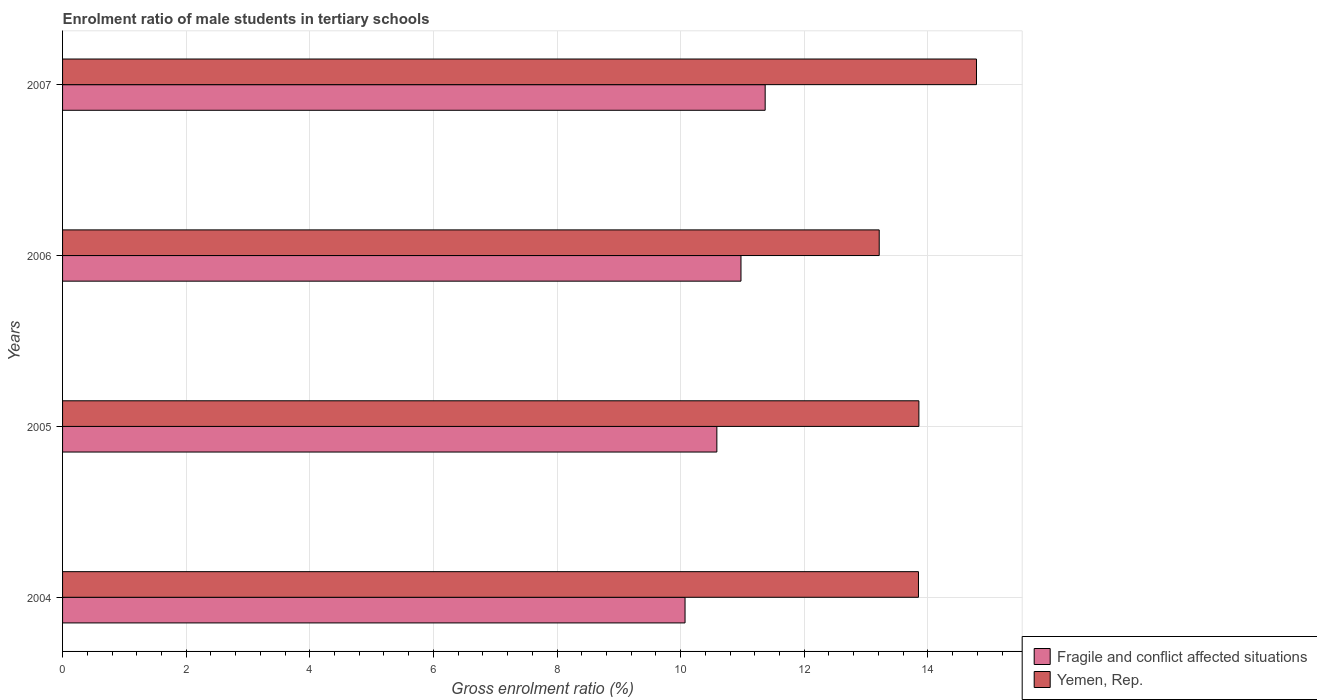How many different coloured bars are there?
Provide a succinct answer. 2. Are the number of bars per tick equal to the number of legend labels?
Your answer should be compact. Yes. What is the label of the 4th group of bars from the top?
Give a very brief answer. 2004. In how many cases, is the number of bars for a given year not equal to the number of legend labels?
Offer a terse response. 0. What is the enrolment ratio of male students in tertiary schools in Fragile and conflict affected situations in 2006?
Ensure brevity in your answer.  10.98. Across all years, what is the maximum enrolment ratio of male students in tertiary schools in Yemen, Rep.?
Offer a very short reply. 14.79. Across all years, what is the minimum enrolment ratio of male students in tertiary schools in Fragile and conflict affected situations?
Provide a succinct answer. 10.07. What is the total enrolment ratio of male students in tertiary schools in Fragile and conflict affected situations in the graph?
Your response must be concise. 43. What is the difference between the enrolment ratio of male students in tertiary schools in Fragile and conflict affected situations in 2004 and that in 2006?
Offer a terse response. -0.9. What is the difference between the enrolment ratio of male students in tertiary schools in Yemen, Rep. in 2004 and the enrolment ratio of male students in tertiary schools in Fragile and conflict affected situations in 2005?
Provide a short and direct response. 3.26. What is the average enrolment ratio of male students in tertiary schools in Yemen, Rep. per year?
Make the answer very short. 13.93. In the year 2004, what is the difference between the enrolment ratio of male students in tertiary schools in Fragile and conflict affected situations and enrolment ratio of male students in tertiary schools in Yemen, Rep.?
Your answer should be compact. -3.78. In how many years, is the enrolment ratio of male students in tertiary schools in Fragile and conflict affected situations greater than 0.8 %?
Give a very brief answer. 4. What is the ratio of the enrolment ratio of male students in tertiary schools in Yemen, Rep. in 2005 to that in 2006?
Ensure brevity in your answer.  1.05. Is the enrolment ratio of male students in tertiary schools in Fragile and conflict affected situations in 2005 less than that in 2007?
Your answer should be compact. Yes. What is the difference between the highest and the second highest enrolment ratio of male students in tertiary schools in Fragile and conflict affected situations?
Keep it short and to the point. 0.39. What is the difference between the highest and the lowest enrolment ratio of male students in tertiary schools in Yemen, Rep.?
Provide a short and direct response. 1.57. What does the 2nd bar from the top in 2006 represents?
Make the answer very short. Fragile and conflict affected situations. What does the 2nd bar from the bottom in 2007 represents?
Offer a very short reply. Yemen, Rep. How many bars are there?
Your response must be concise. 8. What is the difference between two consecutive major ticks on the X-axis?
Offer a very short reply. 2. Are the values on the major ticks of X-axis written in scientific E-notation?
Give a very brief answer. No. Does the graph contain any zero values?
Your answer should be compact. No. Does the graph contain grids?
Make the answer very short. Yes. What is the title of the graph?
Provide a short and direct response. Enrolment ratio of male students in tertiary schools. Does "Peru" appear as one of the legend labels in the graph?
Your answer should be very brief. No. What is the label or title of the X-axis?
Make the answer very short. Gross enrolment ratio (%). What is the Gross enrolment ratio (%) in Fragile and conflict affected situations in 2004?
Offer a terse response. 10.07. What is the Gross enrolment ratio (%) in Yemen, Rep. in 2004?
Your answer should be compact. 13.85. What is the Gross enrolment ratio (%) in Fragile and conflict affected situations in 2005?
Your answer should be very brief. 10.59. What is the Gross enrolment ratio (%) in Yemen, Rep. in 2005?
Ensure brevity in your answer.  13.85. What is the Gross enrolment ratio (%) in Fragile and conflict affected situations in 2006?
Your answer should be very brief. 10.98. What is the Gross enrolment ratio (%) in Yemen, Rep. in 2006?
Ensure brevity in your answer.  13.21. What is the Gross enrolment ratio (%) of Fragile and conflict affected situations in 2007?
Your answer should be very brief. 11.37. What is the Gross enrolment ratio (%) of Yemen, Rep. in 2007?
Keep it short and to the point. 14.79. Across all years, what is the maximum Gross enrolment ratio (%) of Fragile and conflict affected situations?
Give a very brief answer. 11.37. Across all years, what is the maximum Gross enrolment ratio (%) in Yemen, Rep.?
Make the answer very short. 14.79. Across all years, what is the minimum Gross enrolment ratio (%) in Fragile and conflict affected situations?
Keep it short and to the point. 10.07. Across all years, what is the minimum Gross enrolment ratio (%) in Yemen, Rep.?
Provide a short and direct response. 13.21. What is the total Gross enrolment ratio (%) of Fragile and conflict affected situations in the graph?
Give a very brief answer. 43. What is the total Gross enrolment ratio (%) of Yemen, Rep. in the graph?
Give a very brief answer. 55.7. What is the difference between the Gross enrolment ratio (%) in Fragile and conflict affected situations in 2004 and that in 2005?
Keep it short and to the point. -0.51. What is the difference between the Gross enrolment ratio (%) in Yemen, Rep. in 2004 and that in 2005?
Give a very brief answer. -0.01. What is the difference between the Gross enrolment ratio (%) in Fragile and conflict affected situations in 2004 and that in 2006?
Provide a succinct answer. -0.91. What is the difference between the Gross enrolment ratio (%) of Yemen, Rep. in 2004 and that in 2006?
Make the answer very short. 0.64. What is the difference between the Gross enrolment ratio (%) in Fragile and conflict affected situations in 2004 and that in 2007?
Your response must be concise. -1.3. What is the difference between the Gross enrolment ratio (%) in Yemen, Rep. in 2004 and that in 2007?
Provide a short and direct response. -0.94. What is the difference between the Gross enrolment ratio (%) of Fragile and conflict affected situations in 2005 and that in 2006?
Your answer should be compact. -0.39. What is the difference between the Gross enrolment ratio (%) in Yemen, Rep. in 2005 and that in 2006?
Your answer should be compact. 0.64. What is the difference between the Gross enrolment ratio (%) in Fragile and conflict affected situations in 2005 and that in 2007?
Offer a terse response. -0.78. What is the difference between the Gross enrolment ratio (%) of Yemen, Rep. in 2005 and that in 2007?
Your answer should be compact. -0.93. What is the difference between the Gross enrolment ratio (%) in Fragile and conflict affected situations in 2006 and that in 2007?
Provide a short and direct response. -0.39. What is the difference between the Gross enrolment ratio (%) of Yemen, Rep. in 2006 and that in 2007?
Provide a succinct answer. -1.57. What is the difference between the Gross enrolment ratio (%) of Fragile and conflict affected situations in 2004 and the Gross enrolment ratio (%) of Yemen, Rep. in 2005?
Your response must be concise. -3.78. What is the difference between the Gross enrolment ratio (%) in Fragile and conflict affected situations in 2004 and the Gross enrolment ratio (%) in Yemen, Rep. in 2006?
Your answer should be compact. -3.14. What is the difference between the Gross enrolment ratio (%) of Fragile and conflict affected situations in 2004 and the Gross enrolment ratio (%) of Yemen, Rep. in 2007?
Your response must be concise. -4.71. What is the difference between the Gross enrolment ratio (%) of Fragile and conflict affected situations in 2005 and the Gross enrolment ratio (%) of Yemen, Rep. in 2006?
Your answer should be very brief. -2.63. What is the difference between the Gross enrolment ratio (%) of Fragile and conflict affected situations in 2005 and the Gross enrolment ratio (%) of Yemen, Rep. in 2007?
Ensure brevity in your answer.  -4.2. What is the difference between the Gross enrolment ratio (%) of Fragile and conflict affected situations in 2006 and the Gross enrolment ratio (%) of Yemen, Rep. in 2007?
Your answer should be compact. -3.81. What is the average Gross enrolment ratio (%) in Fragile and conflict affected situations per year?
Your answer should be very brief. 10.75. What is the average Gross enrolment ratio (%) in Yemen, Rep. per year?
Offer a terse response. 13.93. In the year 2004, what is the difference between the Gross enrolment ratio (%) of Fragile and conflict affected situations and Gross enrolment ratio (%) of Yemen, Rep.?
Provide a short and direct response. -3.78. In the year 2005, what is the difference between the Gross enrolment ratio (%) in Fragile and conflict affected situations and Gross enrolment ratio (%) in Yemen, Rep.?
Provide a short and direct response. -3.27. In the year 2006, what is the difference between the Gross enrolment ratio (%) in Fragile and conflict affected situations and Gross enrolment ratio (%) in Yemen, Rep.?
Your response must be concise. -2.24. In the year 2007, what is the difference between the Gross enrolment ratio (%) of Fragile and conflict affected situations and Gross enrolment ratio (%) of Yemen, Rep.?
Make the answer very short. -3.42. What is the ratio of the Gross enrolment ratio (%) of Fragile and conflict affected situations in 2004 to that in 2005?
Provide a short and direct response. 0.95. What is the ratio of the Gross enrolment ratio (%) of Yemen, Rep. in 2004 to that in 2005?
Offer a very short reply. 1. What is the ratio of the Gross enrolment ratio (%) in Fragile and conflict affected situations in 2004 to that in 2006?
Your answer should be compact. 0.92. What is the ratio of the Gross enrolment ratio (%) of Yemen, Rep. in 2004 to that in 2006?
Offer a terse response. 1.05. What is the ratio of the Gross enrolment ratio (%) of Fragile and conflict affected situations in 2004 to that in 2007?
Provide a succinct answer. 0.89. What is the ratio of the Gross enrolment ratio (%) in Yemen, Rep. in 2004 to that in 2007?
Keep it short and to the point. 0.94. What is the ratio of the Gross enrolment ratio (%) in Fragile and conflict affected situations in 2005 to that in 2006?
Give a very brief answer. 0.96. What is the ratio of the Gross enrolment ratio (%) of Yemen, Rep. in 2005 to that in 2006?
Make the answer very short. 1.05. What is the ratio of the Gross enrolment ratio (%) of Fragile and conflict affected situations in 2005 to that in 2007?
Your answer should be very brief. 0.93. What is the ratio of the Gross enrolment ratio (%) of Yemen, Rep. in 2005 to that in 2007?
Give a very brief answer. 0.94. What is the ratio of the Gross enrolment ratio (%) of Fragile and conflict affected situations in 2006 to that in 2007?
Provide a succinct answer. 0.97. What is the ratio of the Gross enrolment ratio (%) of Yemen, Rep. in 2006 to that in 2007?
Offer a terse response. 0.89. What is the difference between the highest and the second highest Gross enrolment ratio (%) in Fragile and conflict affected situations?
Give a very brief answer. 0.39. What is the difference between the highest and the second highest Gross enrolment ratio (%) in Yemen, Rep.?
Your response must be concise. 0.93. What is the difference between the highest and the lowest Gross enrolment ratio (%) of Fragile and conflict affected situations?
Offer a terse response. 1.3. What is the difference between the highest and the lowest Gross enrolment ratio (%) in Yemen, Rep.?
Offer a very short reply. 1.57. 